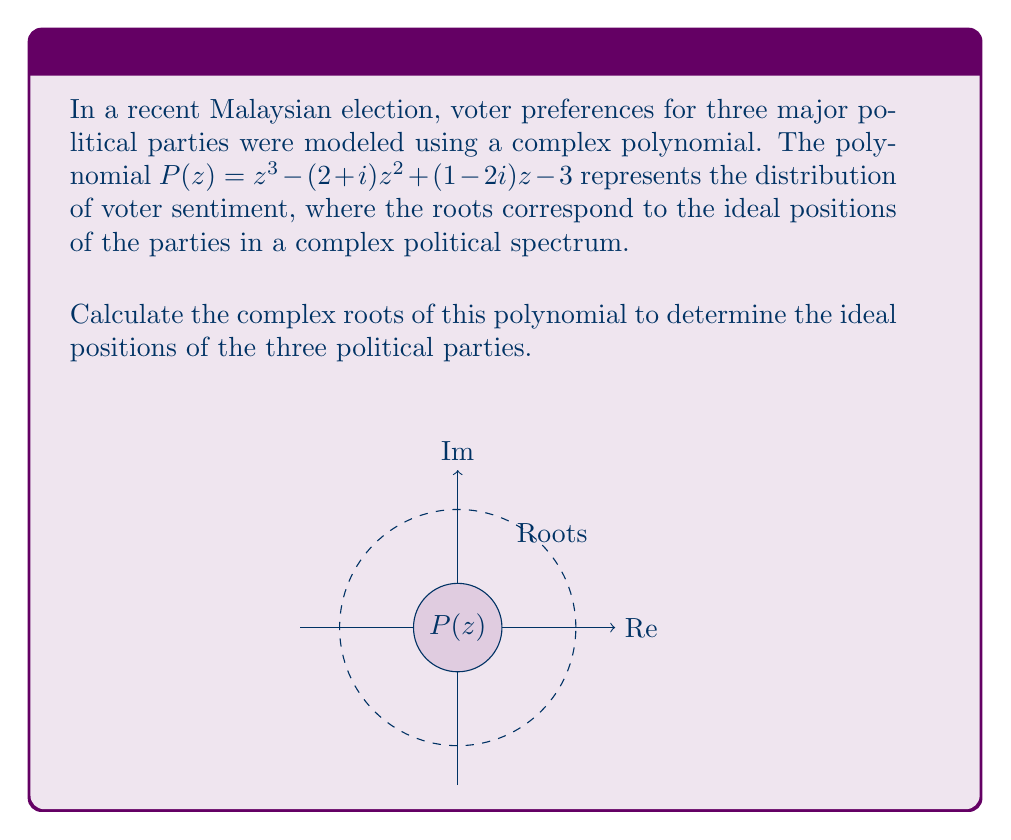What is the answer to this math problem? To find the complex roots of the polynomial $P(z) = z^3 - (2+i)z^2 + (1-2i)z - 3$, we can use the following steps:

1) First, we can try to factor out any real roots. In this case, we can see that $z = 1$ is a root of the polynomial by substitution:

   $P(1) = 1^3 - (2+i)1^2 + (1-2i)1 - 3 = 1 - (2+i) + (1-2i) - 3 = 0$

2) Now we can factor out $(z-1)$:

   $P(z) = (z-1)(z^2 - (1+i)z - 3)$

3) We now need to solve the quadratic equation $z^2 - (1+i)z - 3 = 0$

4) We can use the quadratic formula: $z = \frac{-b \pm \sqrt{b^2 - 4ac}}{2a}$

   Here, $a = 1$, $b = -(1+i)$, and $c = -3$

5) Substituting these values:

   $z = \frac{(1+i) \pm \sqrt{(1+i)^2 + 12}}{2}$

6) Simplify $(1+i)^2 = 1 + 2i - 1 = 2i$

   $z = \frac{(1+i) \pm \sqrt{2i + 12}}{2} = \frac{(1+i) \pm \sqrt{12 + 2i}}{2}$

7) To simplify $\sqrt{12 + 2i}$, let's use the formula $\sqrt{a+bi} = \sqrt{\frac{\sqrt{a^2+b^2}+a}{2}} + i\cdot\text{sign}(b)\sqrt{\frac{\sqrt{a^2+b^2}-a}{2}}$

   Here, $a = 12$ and $b = 2$

   $\sqrt{12 + 2i} = \sqrt{\frac{\sqrt{144+4}+12}{2}} + i\sqrt{\frac{\sqrt{144+4}-12}{2}} = \sqrt{\frac{\sqrt{148}+12}{2}} + i\sqrt{\frac{\sqrt{148}-12}{2}}$

8) This gives us the final two roots:

   $z_2 = \frac{1+i + \sqrt{\frac{\sqrt{148}+12}{2}} + i\sqrt{\frac{\sqrt{148}-12}{2}}}{2}$

   $z_3 = \frac{1+i - \sqrt{\frac{\sqrt{148}+12}{2}} - i\sqrt{\frac{\sqrt{148}-12}{2}}}{2}$

Therefore, the three roots are $z_1 = 1$, $z_2$, and $z_3$ as calculated above.
Answer: $z_1 = 1$, $z_2 = \frac{1+i + \sqrt{\frac{\sqrt{148}+12}{2}} + i\sqrt{\frac{\sqrt{148}-12}{2}}}{2}$, $z_3 = \frac{1+i - \sqrt{\frac{\sqrt{148}+12}{2}} - i\sqrt{\frac{\sqrt{148}-12}{2}}}{2}$ 